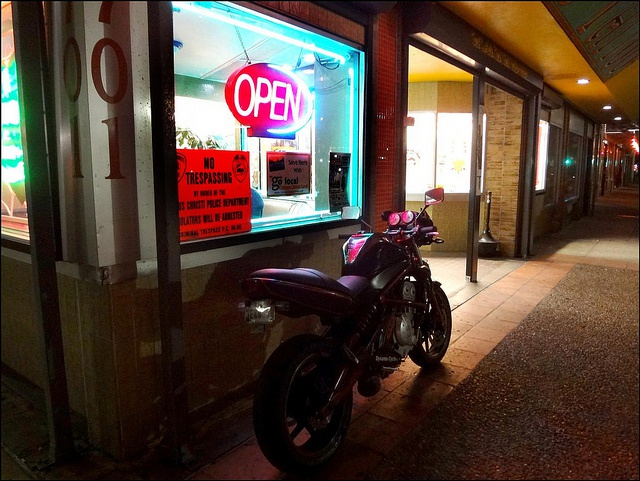Describe the objects in this image and their specific colors. I can see a motorcycle in black, maroon, gray, and ivory tones in this image. 